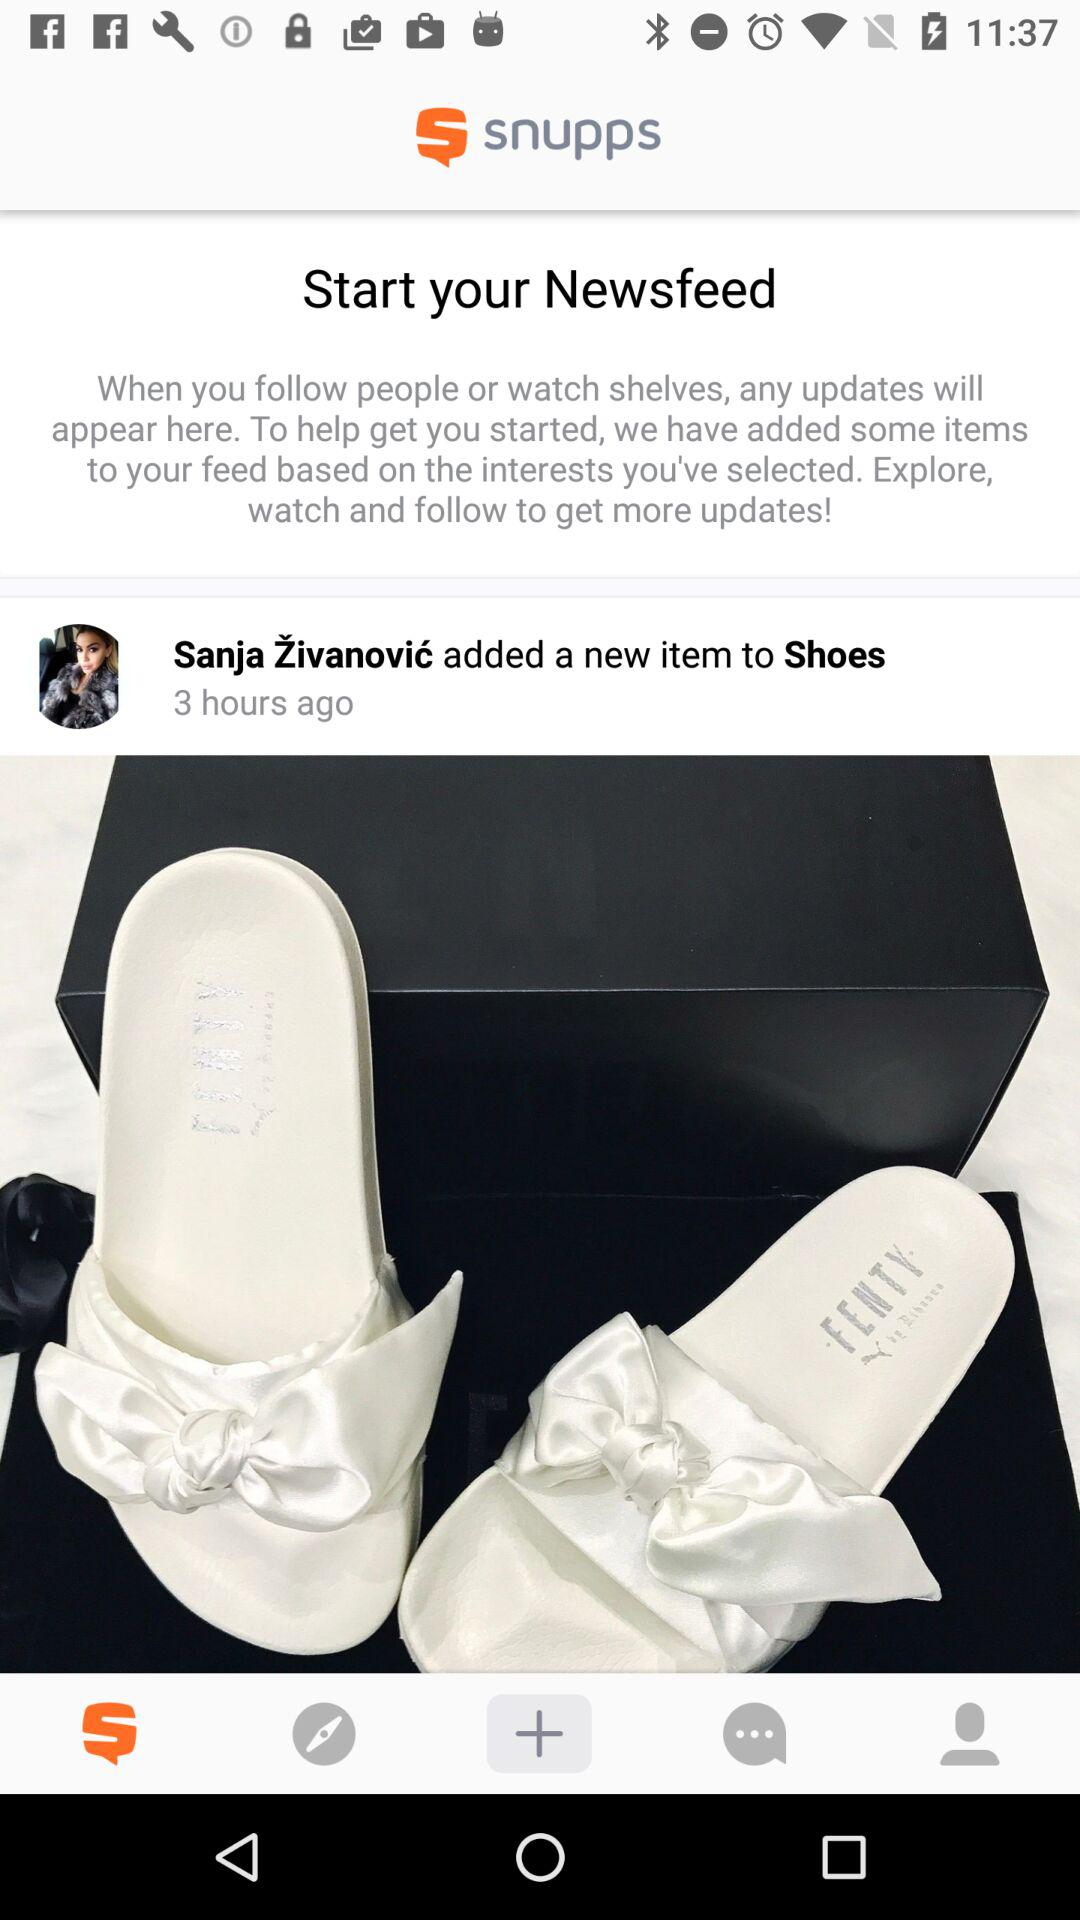How many items are there in the Newsfeed?
Answer the question using a single word or phrase. 1 